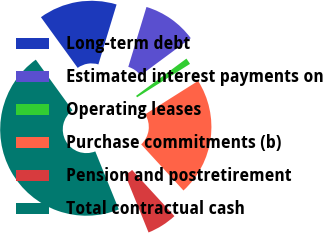Convert chart. <chart><loc_0><loc_0><loc_500><loc_500><pie_chart><fcel>Long-term debt<fcel>Estimated interest payments on<fcel>Operating leases<fcel>Purchase commitments (b)<fcel>Pension and postretirement<fcel>Total contractual cash<nl><fcel>14.67%<fcel>10.17%<fcel>1.18%<fcel>22.15%<fcel>5.68%<fcel>46.15%<nl></chart> 